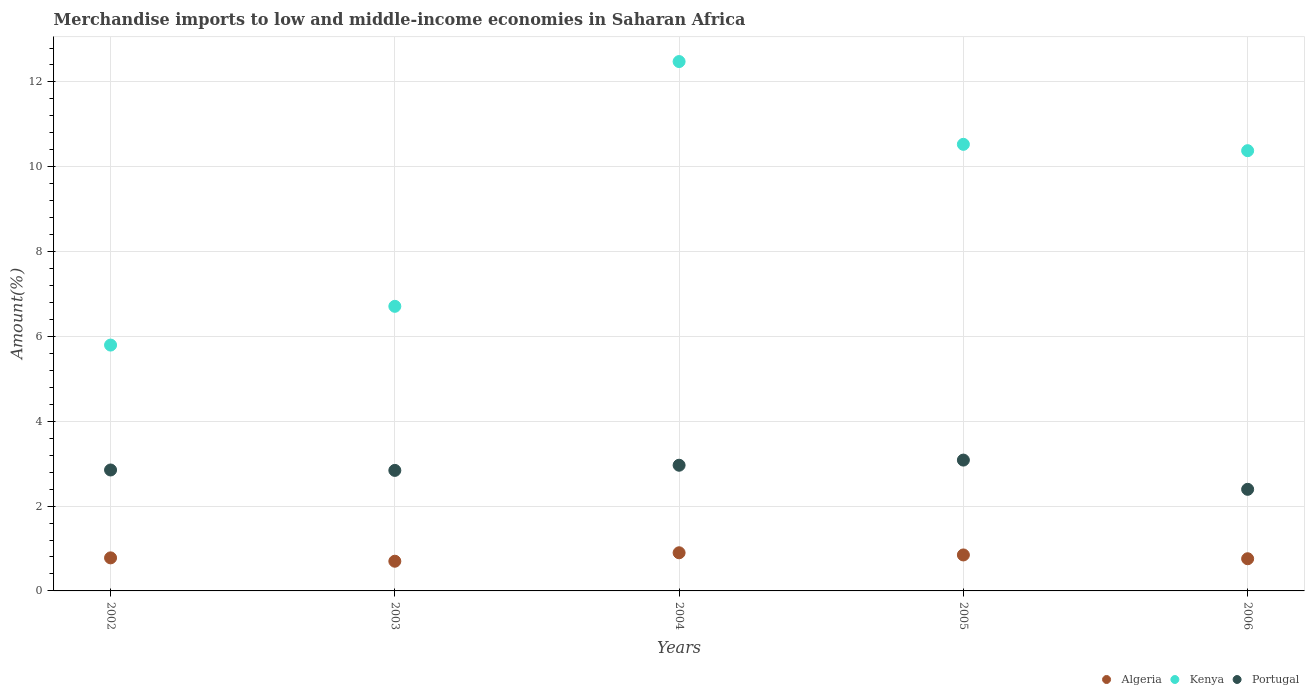Is the number of dotlines equal to the number of legend labels?
Keep it short and to the point. Yes. What is the percentage of amount earned from merchandise imports in Algeria in 2005?
Your answer should be very brief. 0.85. Across all years, what is the maximum percentage of amount earned from merchandise imports in Kenya?
Ensure brevity in your answer.  12.48. Across all years, what is the minimum percentage of amount earned from merchandise imports in Kenya?
Your response must be concise. 5.8. In which year was the percentage of amount earned from merchandise imports in Algeria minimum?
Provide a short and direct response. 2003. What is the total percentage of amount earned from merchandise imports in Kenya in the graph?
Your answer should be very brief. 45.9. What is the difference between the percentage of amount earned from merchandise imports in Portugal in 2002 and that in 2005?
Keep it short and to the point. -0.23. What is the difference between the percentage of amount earned from merchandise imports in Kenya in 2004 and the percentage of amount earned from merchandise imports in Portugal in 2003?
Ensure brevity in your answer.  9.64. What is the average percentage of amount earned from merchandise imports in Algeria per year?
Provide a short and direct response. 0.8. In the year 2004, what is the difference between the percentage of amount earned from merchandise imports in Portugal and percentage of amount earned from merchandise imports in Kenya?
Offer a terse response. -9.52. In how many years, is the percentage of amount earned from merchandise imports in Portugal greater than 6.4 %?
Make the answer very short. 0. What is the ratio of the percentage of amount earned from merchandise imports in Portugal in 2004 to that in 2006?
Your answer should be very brief. 1.24. Is the percentage of amount earned from merchandise imports in Algeria in 2002 less than that in 2005?
Make the answer very short. Yes. What is the difference between the highest and the second highest percentage of amount earned from merchandise imports in Portugal?
Provide a succinct answer. 0.12. What is the difference between the highest and the lowest percentage of amount earned from merchandise imports in Portugal?
Your answer should be very brief. 0.69. Does the percentage of amount earned from merchandise imports in Portugal monotonically increase over the years?
Ensure brevity in your answer.  No. Is the percentage of amount earned from merchandise imports in Portugal strictly greater than the percentage of amount earned from merchandise imports in Kenya over the years?
Provide a succinct answer. No. Are the values on the major ticks of Y-axis written in scientific E-notation?
Ensure brevity in your answer.  No. Does the graph contain any zero values?
Provide a succinct answer. No. Does the graph contain grids?
Your answer should be compact. Yes. How are the legend labels stacked?
Provide a succinct answer. Horizontal. What is the title of the graph?
Keep it short and to the point. Merchandise imports to low and middle-income economies in Saharan Africa. What is the label or title of the X-axis?
Offer a terse response. Years. What is the label or title of the Y-axis?
Provide a succinct answer. Amount(%). What is the Amount(%) in Algeria in 2002?
Your answer should be very brief. 0.78. What is the Amount(%) in Kenya in 2002?
Give a very brief answer. 5.8. What is the Amount(%) in Portugal in 2002?
Keep it short and to the point. 2.85. What is the Amount(%) in Algeria in 2003?
Keep it short and to the point. 0.7. What is the Amount(%) in Kenya in 2003?
Make the answer very short. 6.71. What is the Amount(%) of Portugal in 2003?
Provide a short and direct response. 2.84. What is the Amount(%) of Algeria in 2004?
Offer a terse response. 0.9. What is the Amount(%) in Kenya in 2004?
Offer a very short reply. 12.48. What is the Amount(%) of Portugal in 2004?
Keep it short and to the point. 2.96. What is the Amount(%) of Algeria in 2005?
Provide a short and direct response. 0.85. What is the Amount(%) of Kenya in 2005?
Offer a terse response. 10.53. What is the Amount(%) in Portugal in 2005?
Keep it short and to the point. 3.08. What is the Amount(%) of Algeria in 2006?
Your response must be concise. 0.76. What is the Amount(%) of Kenya in 2006?
Offer a very short reply. 10.38. What is the Amount(%) of Portugal in 2006?
Make the answer very short. 2.4. Across all years, what is the maximum Amount(%) of Algeria?
Offer a very short reply. 0.9. Across all years, what is the maximum Amount(%) of Kenya?
Your answer should be very brief. 12.48. Across all years, what is the maximum Amount(%) of Portugal?
Provide a short and direct response. 3.08. Across all years, what is the minimum Amount(%) in Algeria?
Ensure brevity in your answer.  0.7. Across all years, what is the minimum Amount(%) of Kenya?
Make the answer very short. 5.8. Across all years, what is the minimum Amount(%) of Portugal?
Your response must be concise. 2.4. What is the total Amount(%) in Algeria in the graph?
Give a very brief answer. 3.99. What is the total Amount(%) in Kenya in the graph?
Offer a terse response. 45.9. What is the total Amount(%) of Portugal in the graph?
Your answer should be compact. 14.14. What is the difference between the Amount(%) in Algeria in 2002 and that in 2003?
Your answer should be very brief. 0.08. What is the difference between the Amount(%) of Kenya in 2002 and that in 2003?
Your answer should be very brief. -0.91. What is the difference between the Amount(%) of Portugal in 2002 and that in 2003?
Offer a very short reply. 0.01. What is the difference between the Amount(%) of Algeria in 2002 and that in 2004?
Offer a terse response. -0.12. What is the difference between the Amount(%) in Kenya in 2002 and that in 2004?
Provide a succinct answer. -6.68. What is the difference between the Amount(%) of Portugal in 2002 and that in 2004?
Your answer should be compact. -0.11. What is the difference between the Amount(%) in Algeria in 2002 and that in 2005?
Keep it short and to the point. -0.07. What is the difference between the Amount(%) of Kenya in 2002 and that in 2005?
Give a very brief answer. -4.73. What is the difference between the Amount(%) of Portugal in 2002 and that in 2005?
Ensure brevity in your answer.  -0.23. What is the difference between the Amount(%) in Algeria in 2002 and that in 2006?
Ensure brevity in your answer.  0.02. What is the difference between the Amount(%) of Kenya in 2002 and that in 2006?
Offer a terse response. -4.58. What is the difference between the Amount(%) of Portugal in 2002 and that in 2006?
Keep it short and to the point. 0.46. What is the difference between the Amount(%) in Algeria in 2003 and that in 2004?
Make the answer very short. -0.2. What is the difference between the Amount(%) in Kenya in 2003 and that in 2004?
Keep it short and to the point. -5.77. What is the difference between the Amount(%) of Portugal in 2003 and that in 2004?
Your answer should be very brief. -0.12. What is the difference between the Amount(%) in Algeria in 2003 and that in 2005?
Provide a succinct answer. -0.15. What is the difference between the Amount(%) in Kenya in 2003 and that in 2005?
Provide a short and direct response. -3.82. What is the difference between the Amount(%) in Portugal in 2003 and that in 2005?
Ensure brevity in your answer.  -0.24. What is the difference between the Amount(%) of Algeria in 2003 and that in 2006?
Make the answer very short. -0.06. What is the difference between the Amount(%) in Kenya in 2003 and that in 2006?
Provide a short and direct response. -3.67. What is the difference between the Amount(%) of Portugal in 2003 and that in 2006?
Keep it short and to the point. 0.45. What is the difference between the Amount(%) of Algeria in 2004 and that in 2005?
Offer a terse response. 0.05. What is the difference between the Amount(%) in Kenya in 2004 and that in 2005?
Keep it short and to the point. 1.95. What is the difference between the Amount(%) in Portugal in 2004 and that in 2005?
Give a very brief answer. -0.12. What is the difference between the Amount(%) in Algeria in 2004 and that in 2006?
Make the answer very short. 0.14. What is the difference between the Amount(%) of Kenya in 2004 and that in 2006?
Offer a terse response. 2.1. What is the difference between the Amount(%) in Portugal in 2004 and that in 2006?
Offer a very short reply. 0.57. What is the difference between the Amount(%) in Algeria in 2005 and that in 2006?
Your answer should be very brief. 0.09. What is the difference between the Amount(%) of Kenya in 2005 and that in 2006?
Ensure brevity in your answer.  0.15. What is the difference between the Amount(%) of Portugal in 2005 and that in 2006?
Provide a succinct answer. 0.69. What is the difference between the Amount(%) of Algeria in 2002 and the Amount(%) of Kenya in 2003?
Provide a succinct answer. -5.93. What is the difference between the Amount(%) of Algeria in 2002 and the Amount(%) of Portugal in 2003?
Your answer should be compact. -2.06. What is the difference between the Amount(%) of Kenya in 2002 and the Amount(%) of Portugal in 2003?
Your answer should be very brief. 2.95. What is the difference between the Amount(%) of Algeria in 2002 and the Amount(%) of Kenya in 2004?
Make the answer very short. -11.7. What is the difference between the Amount(%) in Algeria in 2002 and the Amount(%) in Portugal in 2004?
Offer a terse response. -2.18. What is the difference between the Amount(%) of Kenya in 2002 and the Amount(%) of Portugal in 2004?
Provide a short and direct response. 2.83. What is the difference between the Amount(%) in Algeria in 2002 and the Amount(%) in Kenya in 2005?
Your response must be concise. -9.75. What is the difference between the Amount(%) in Algeria in 2002 and the Amount(%) in Portugal in 2005?
Your answer should be compact. -2.31. What is the difference between the Amount(%) in Kenya in 2002 and the Amount(%) in Portugal in 2005?
Provide a short and direct response. 2.71. What is the difference between the Amount(%) of Algeria in 2002 and the Amount(%) of Kenya in 2006?
Make the answer very short. -9.6. What is the difference between the Amount(%) in Algeria in 2002 and the Amount(%) in Portugal in 2006?
Offer a terse response. -1.62. What is the difference between the Amount(%) in Kenya in 2002 and the Amount(%) in Portugal in 2006?
Your response must be concise. 3.4. What is the difference between the Amount(%) of Algeria in 2003 and the Amount(%) of Kenya in 2004?
Provide a succinct answer. -11.78. What is the difference between the Amount(%) in Algeria in 2003 and the Amount(%) in Portugal in 2004?
Your answer should be compact. -2.26. What is the difference between the Amount(%) of Kenya in 2003 and the Amount(%) of Portugal in 2004?
Give a very brief answer. 3.75. What is the difference between the Amount(%) in Algeria in 2003 and the Amount(%) in Kenya in 2005?
Give a very brief answer. -9.83. What is the difference between the Amount(%) of Algeria in 2003 and the Amount(%) of Portugal in 2005?
Your answer should be compact. -2.38. What is the difference between the Amount(%) in Kenya in 2003 and the Amount(%) in Portugal in 2005?
Provide a succinct answer. 3.63. What is the difference between the Amount(%) in Algeria in 2003 and the Amount(%) in Kenya in 2006?
Your answer should be compact. -9.68. What is the difference between the Amount(%) of Algeria in 2003 and the Amount(%) of Portugal in 2006?
Offer a very short reply. -1.7. What is the difference between the Amount(%) of Kenya in 2003 and the Amount(%) of Portugal in 2006?
Keep it short and to the point. 4.31. What is the difference between the Amount(%) of Algeria in 2004 and the Amount(%) of Kenya in 2005?
Offer a very short reply. -9.63. What is the difference between the Amount(%) of Algeria in 2004 and the Amount(%) of Portugal in 2005?
Your answer should be very brief. -2.19. What is the difference between the Amount(%) of Kenya in 2004 and the Amount(%) of Portugal in 2005?
Provide a short and direct response. 9.4. What is the difference between the Amount(%) of Algeria in 2004 and the Amount(%) of Kenya in 2006?
Offer a very short reply. -9.48. What is the difference between the Amount(%) in Algeria in 2004 and the Amount(%) in Portugal in 2006?
Offer a very short reply. -1.5. What is the difference between the Amount(%) of Kenya in 2004 and the Amount(%) of Portugal in 2006?
Give a very brief answer. 10.09. What is the difference between the Amount(%) in Algeria in 2005 and the Amount(%) in Kenya in 2006?
Make the answer very short. -9.53. What is the difference between the Amount(%) of Algeria in 2005 and the Amount(%) of Portugal in 2006?
Your answer should be compact. -1.55. What is the difference between the Amount(%) in Kenya in 2005 and the Amount(%) in Portugal in 2006?
Offer a very short reply. 8.13. What is the average Amount(%) in Algeria per year?
Provide a short and direct response. 0.8. What is the average Amount(%) in Kenya per year?
Ensure brevity in your answer.  9.18. What is the average Amount(%) of Portugal per year?
Make the answer very short. 2.83. In the year 2002, what is the difference between the Amount(%) of Algeria and Amount(%) of Kenya?
Make the answer very short. -5.02. In the year 2002, what is the difference between the Amount(%) in Algeria and Amount(%) in Portugal?
Offer a very short reply. -2.07. In the year 2002, what is the difference between the Amount(%) in Kenya and Amount(%) in Portugal?
Provide a short and direct response. 2.95. In the year 2003, what is the difference between the Amount(%) in Algeria and Amount(%) in Kenya?
Your answer should be very brief. -6.01. In the year 2003, what is the difference between the Amount(%) of Algeria and Amount(%) of Portugal?
Keep it short and to the point. -2.14. In the year 2003, what is the difference between the Amount(%) in Kenya and Amount(%) in Portugal?
Give a very brief answer. 3.87. In the year 2004, what is the difference between the Amount(%) of Algeria and Amount(%) of Kenya?
Your response must be concise. -11.58. In the year 2004, what is the difference between the Amount(%) in Algeria and Amount(%) in Portugal?
Offer a very short reply. -2.06. In the year 2004, what is the difference between the Amount(%) of Kenya and Amount(%) of Portugal?
Ensure brevity in your answer.  9.52. In the year 2005, what is the difference between the Amount(%) in Algeria and Amount(%) in Kenya?
Make the answer very short. -9.68. In the year 2005, what is the difference between the Amount(%) of Algeria and Amount(%) of Portugal?
Give a very brief answer. -2.24. In the year 2005, what is the difference between the Amount(%) in Kenya and Amount(%) in Portugal?
Your answer should be very brief. 7.44. In the year 2006, what is the difference between the Amount(%) in Algeria and Amount(%) in Kenya?
Ensure brevity in your answer.  -9.62. In the year 2006, what is the difference between the Amount(%) of Algeria and Amount(%) of Portugal?
Make the answer very short. -1.64. In the year 2006, what is the difference between the Amount(%) in Kenya and Amount(%) in Portugal?
Ensure brevity in your answer.  7.98. What is the ratio of the Amount(%) in Algeria in 2002 to that in 2003?
Provide a succinct answer. 1.11. What is the ratio of the Amount(%) in Kenya in 2002 to that in 2003?
Provide a short and direct response. 0.86. What is the ratio of the Amount(%) of Algeria in 2002 to that in 2004?
Offer a terse response. 0.87. What is the ratio of the Amount(%) in Kenya in 2002 to that in 2004?
Your response must be concise. 0.46. What is the ratio of the Amount(%) of Portugal in 2002 to that in 2004?
Provide a short and direct response. 0.96. What is the ratio of the Amount(%) in Algeria in 2002 to that in 2005?
Provide a short and direct response. 0.92. What is the ratio of the Amount(%) of Kenya in 2002 to that in 2005?
Your answer should be very brief. 0.55. What is the ratio of the Amount(%) in Portugal in 2002 to that in 2005?
Make the answer very short. 0.92. What is the ratio of the Amount(%) of Algeria in 2002 to that in 2006?
Offer a very short reply. 1.03. What is the ratio of the Amount(%) of Kenya in 2002 to that in 2006?
Keep it short and to the point. 0.56. What is the ratio of the Amount(%) of Portugal in 2002 to that in 2006?
Your response must be concise. 1.19. What is the ratio of the Amount(%) in Algeria in 2003 to that in 2004?
Your answer should be compact. 0.78. What is the ratio of the Amount(%) in Kenya in 2003 to that in 2004?
Provide a succinct answer. 0.54. What is the ratio of the Amount(%) in Portugal in 2003 to that in 2004?
Your answer should be very brief. 0.96. What is the ratio of the Amount(%) of Algeria in 2003 to that in 2005?
Give a very brief answer. 0.83. What is the ratio of the Amount(%) in Kenya in 2003 to that in 2005?
Provide a short and direct response. 0.64. What is the ratio of the Amount(%) of Portugal in 2003 to that in 2005?
Offer a terse response. 0.92. What is the ratio of the Amount(%) of Algeria in 2003 to that in 2006?
Your answer should be very brief. 0.92. What is the ratio of the Amount(%) of Kenya in 2003 to that in 2006?
Provide a succinct answer. 0.65. What is the ratio of the Amount(%) of Portugal in 2003 to that in 2006?
Keep it short and to the point. 1.19. What is the ratio of the Amount(%) of Algeria in 2004 to that in 2005?
Your answer should be compact. 1.06. What is the ratio of the Amount(%) in Kenya in 2004 to that in 2005?
Keep it short and to the point. 1.19. What is the ratio of the Amount(%) in Portugal in 2004 to that in 2005?
Provide a succinct answer. 0.96. What is the ratio of the Amount(%) in Algeria in 2004 to that in 2006?
Provide a succinct answer. 1.19. What is the ratio of the Amount(%) of Kenya in 2004 to that in 2006?
Offer a very short reply. 1.2. What is the ratio of the Amount(%) in Portugal in 2004 to that in 2006?
Offer a terse response. 1.24. What is the ratio of the Amount(%) of Algeria in 2005 to that in 2006?
Give a very brief answer. 1.12. What is the ratio of the Amount(%) of Kenya in 2005 to that in 2006?
Provide a succinct answer. 1.01. What is the ratio of the Amount(%) in Portugal in 2005 to that in 2006?
Offer a terse response. 1.29. What is the difference between the highest and the second highest Amount(%) of Algeria?
Give a very brief answer. 0.05. What is the difference between the highest and the second highest Amount(%) in Kenya?
Offer a very short reply. 1.95. What is the difference between the highest and the second highest Amount(%) of Portugal?
Keep it short and to the point. 0.12. What is the difference between the highest and the lowest Amount(%) in Algeria?
Keep it short and to the point. 0.2. What is the difference between the highest and the lowest Amount(%) of Kenya?
Keep it short and to the point. 6.68. What is the difference between the highest and the lowest Amount(%) in Portugal?
Provide a short and direct response. 0.69. 